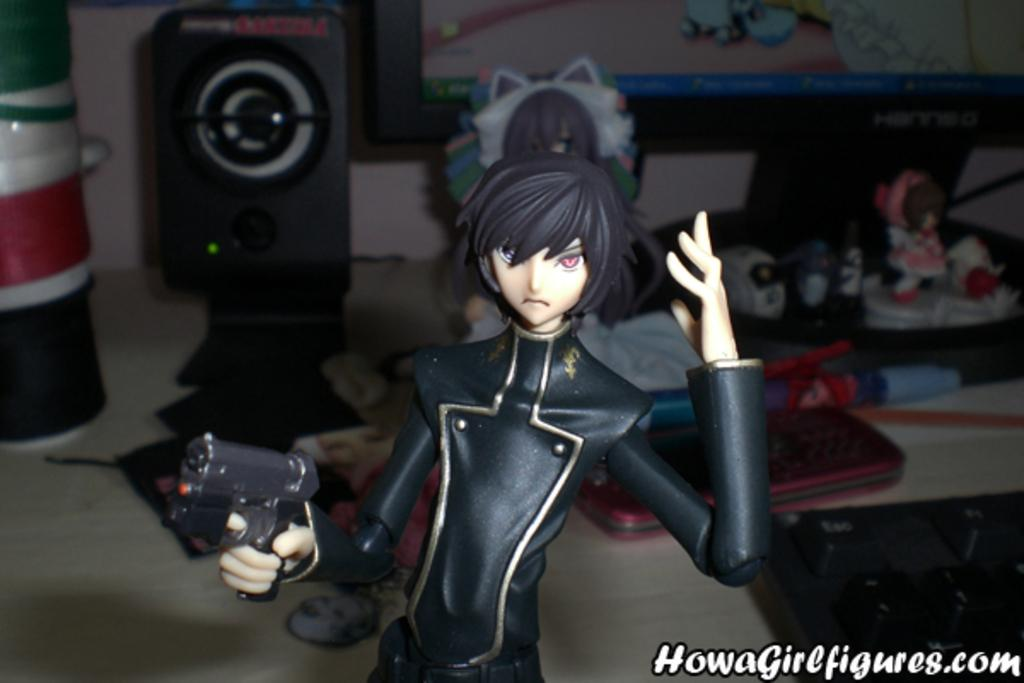What is the person in the image holding? The person is holding a gun in the image. What objects can be seen besides the person holding the gun? There are buckets, a speaker, toys, and a monitor in the image. What might be used for amplifying sound in the image? The speaker in the image can be used for amplifying sound. What might be used for displaying visual information in the image? The monitor in the image can be used for displaying visual information. How many beans are visible in the image? There are no beans present in the image. What type of root can be seen growing in the image? There is no root visible in the image. 